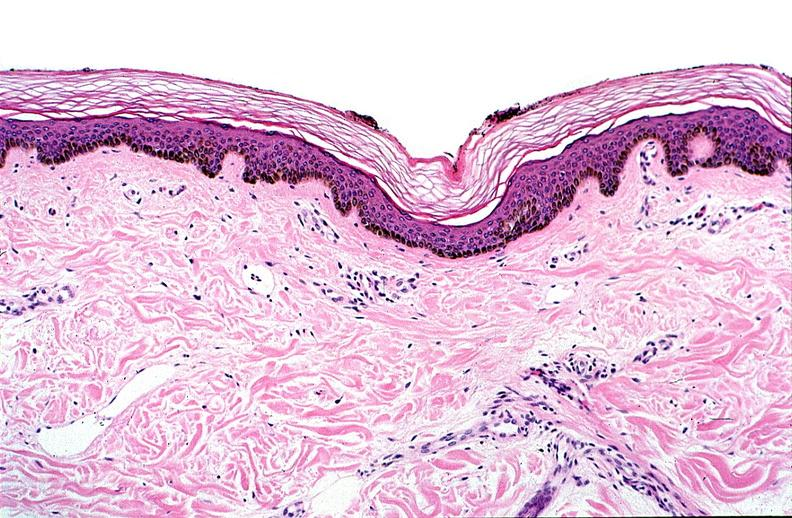what does this image show?
Answer the question using a single word or phrase. Thermal burned skin 